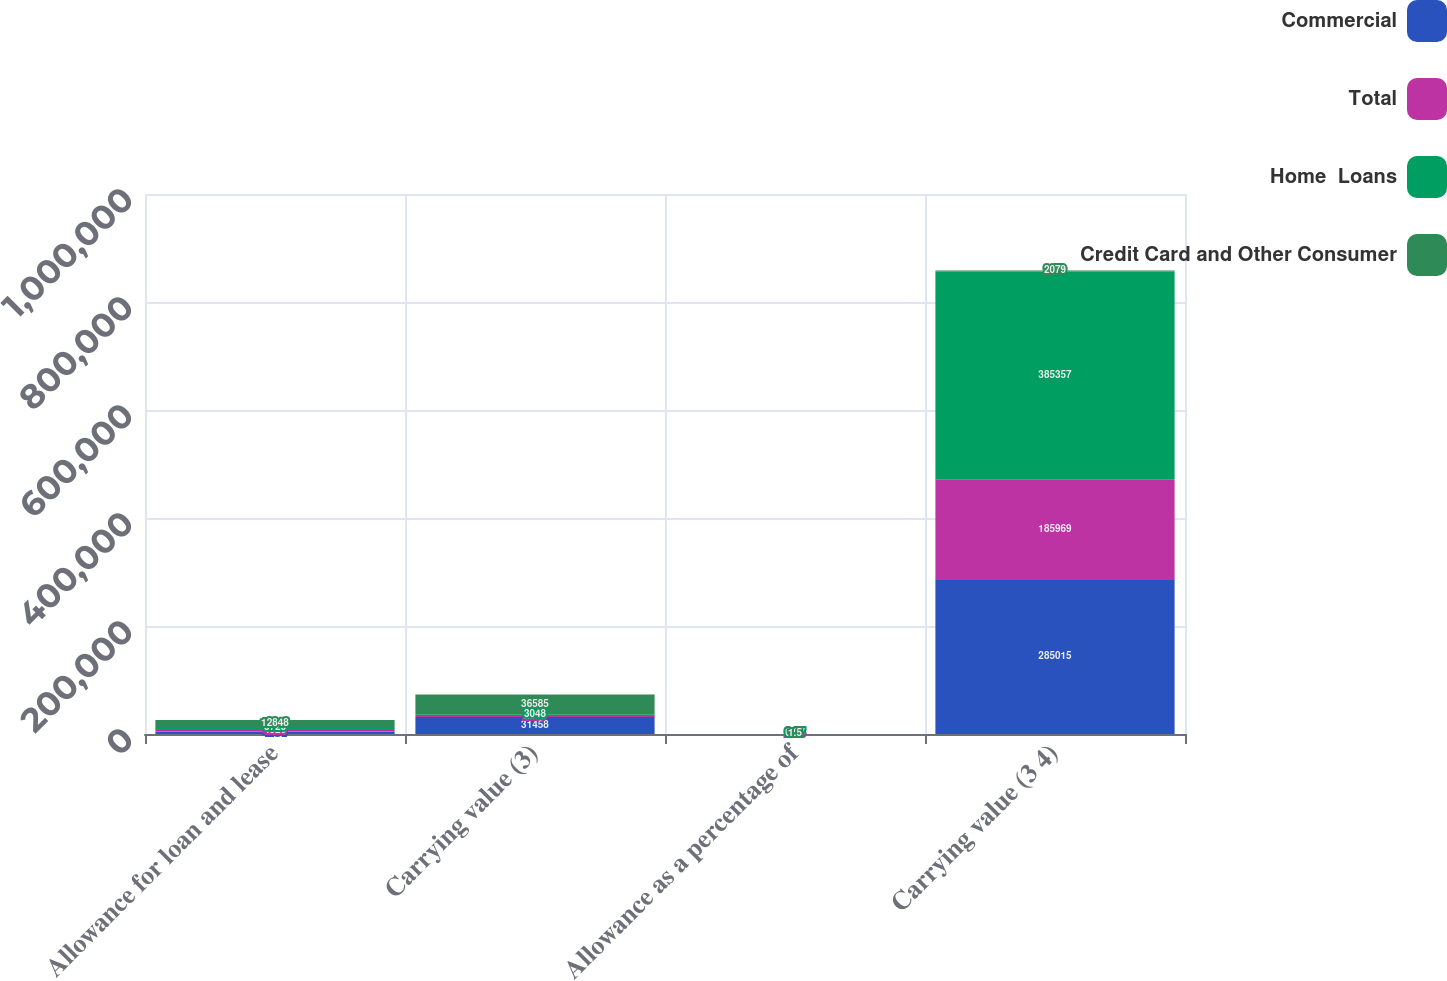Convert chart. <chart><loc_0><loc_0><loc_500><loc_500><stacked_bar_chart><ecel><fcel>Allowance for loan and lease<fcel>Carrying value (3)<fcel>Allowance as a percentage of<fcel>Carrying value (3 4)<nl><fcel>Commercial<fcel>4794<fcel>31458<fcel>1.68<fcel>285015<nl><fcel>Total<fcel>4326<fcel>2079<fcel>2.33<fcel>185969<nl><fcel>Home  Loans<fcel>3728<fcel>3048<fcel>0.97<fcel>385357<nl><fcel>Credit Card and Other Consumer<fcel>12848<fcel>36585<fcel>1.5<fcel>2079<nl></chart> 